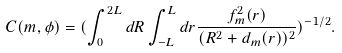<formula> <loc_0><loc_0><loc_500><loc_500>C ( m , \phi ) = ( \int _ { 0 } ^ { 2 L } d R \int _ { - L } ^ { L } d r \frac { f _ { m } ^ { 2 } ( r ) } { ( R ^ { 2 } + d _ { m } ( r ) ) ^ { 2 } } ) ^ { - 1 / 2 } .</formula> 